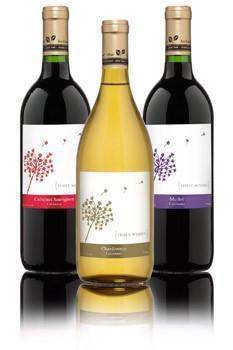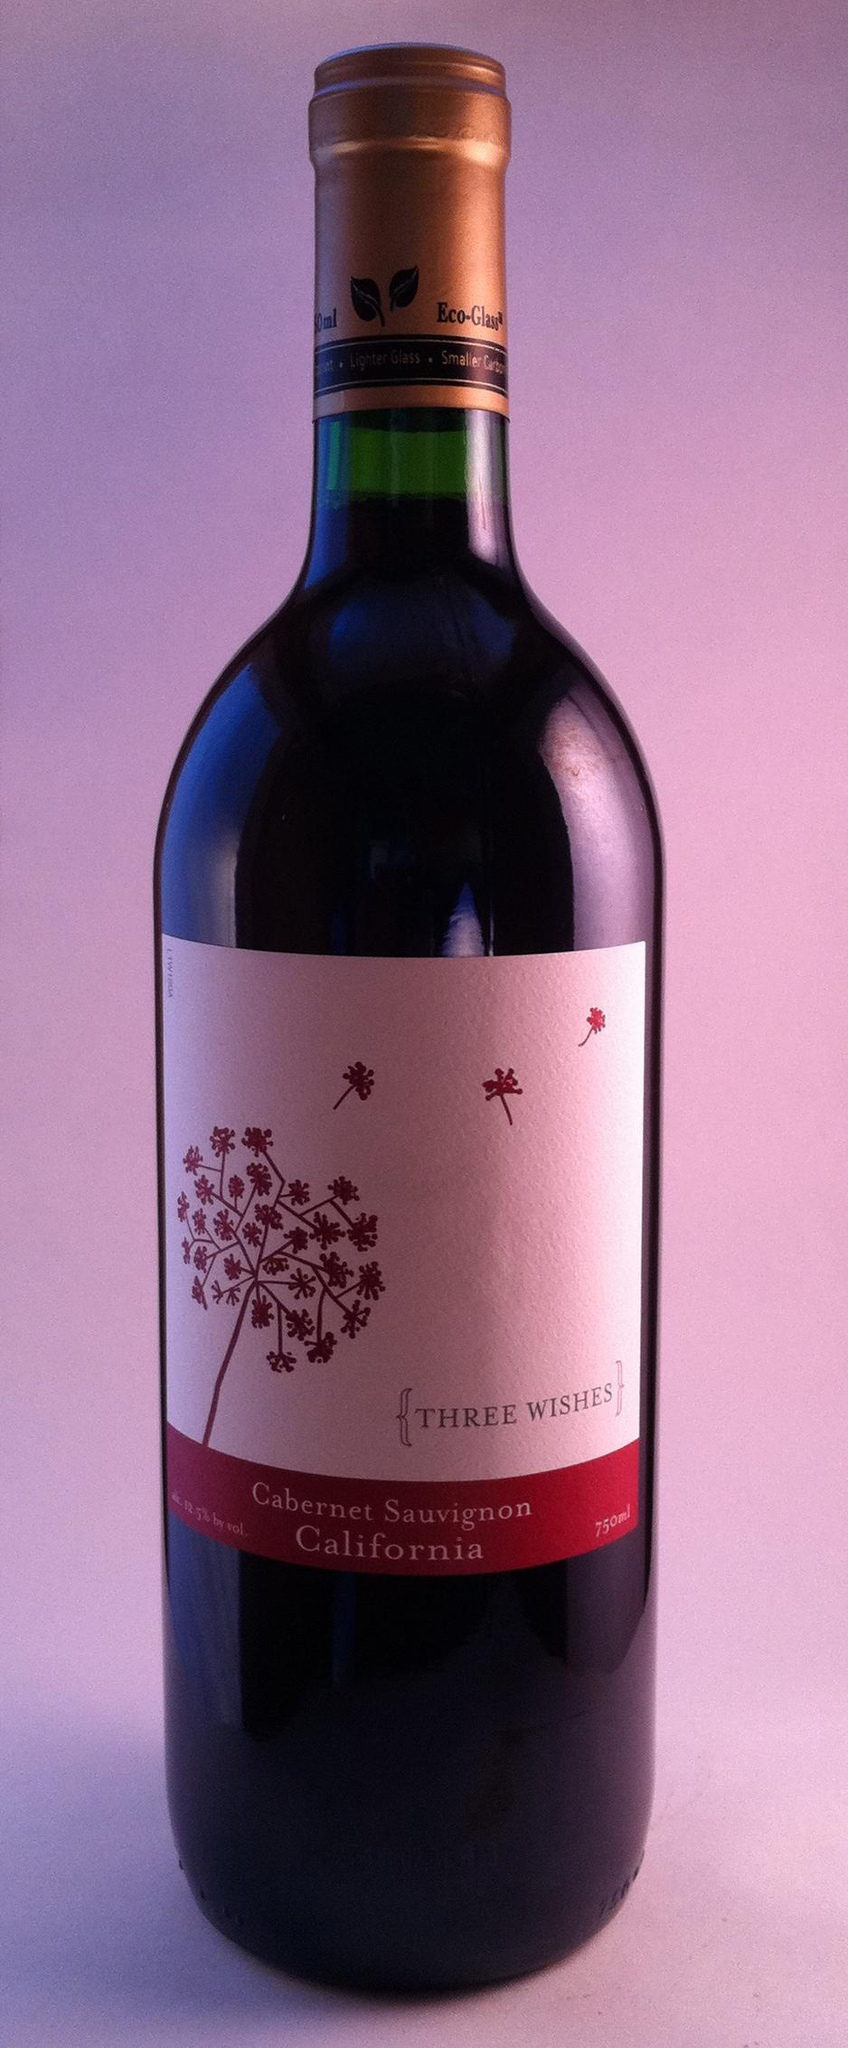The first image is the image on the left, the second image is the image on the right. Evaluate the accuracy of this statement regarding the images: "There are exactly three bottles of wine featured in one of the images.". Is it true? Answer yes or no. Yes. 